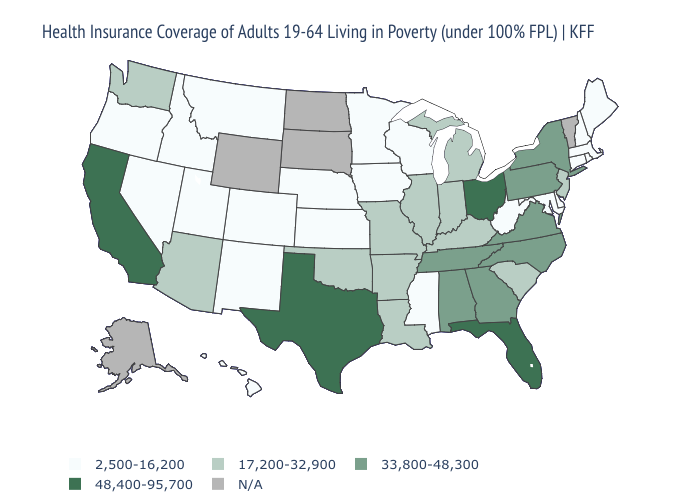How many symbols are there in the legend?
Quick response, please. 5. Name the states that have a value in the range 33,800-48,300?
Answer briefly. Alabama, Georgia, New York, North Carolina, Pennsylvania, Tennessee, Virginia. What is the value of New Mexico?
Quick response, please. 2,500-16,200. Name the states that have a value in the range 33,800-48,300?
Concise answer only. Alabama, Georgia, New York, North Carolina, Pennsylvania, Tennessee, Virginia. What is the value of Virginia?
Keep it brief. 33,800-48,300. Which states have the highest value in the USA?
Short answer required. California, Florida, Ohio, Texas. Name the states that have a value in the range 17,200-32,900?
Quick response, please. Arizona, Arkansas, Illinois, Indiana, Kentucky, Louisiana, Michigan, Missouri, New Jersey, Oklahoma, South Carolina, Washington. Among the states that border Iowa , which have the highest value?
Write a very short answer. Illinois, Missouri. Name the states that have a value in the range 2,500-16,200?
Write a very short answer. Colorado, Connecticut, Delaware, Hawaii, Idaho, Iowa, Kansas, Maine, Maryland, Massachusetts, Minnesota, Mississippi, Montana, Nebraska, Nevada, New Hampshire, New Mexico, Oregon, Rhode Island, Utah, West Virginia, Wisconsin. What is the value of Virginia?
Be succinct. 33,800-48,300. Which states have the lowest value in the USA?
Quick response, please. Colorado, Connecticut, Delaware, Hawaii, Idaho, Iowa, Kansas, Maine, Maryland, Massachusetts, Minnesota, Mississippi, Montana, Nebraska, Nevada, New Hampshire, New Mexico, Oregon, Rhode Island, Utah, West Virginia, Wisconsin. What is the highest value in states that border Colorado?
Give a very brief answer. 17,200-32,900. 